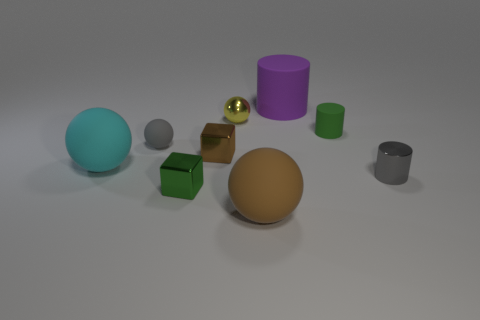How are the objects arranged in relation to each other? The objects are spaced out with no particular pattern, positioned randomly on a flat surface, giving the scene a somewhat scattered appearance. Does this arrangement suggest any particular theme or purpose? The arrangement might be illustrating a study in shapes, colors, and textures, or a visual representation of diversity and individuality. 